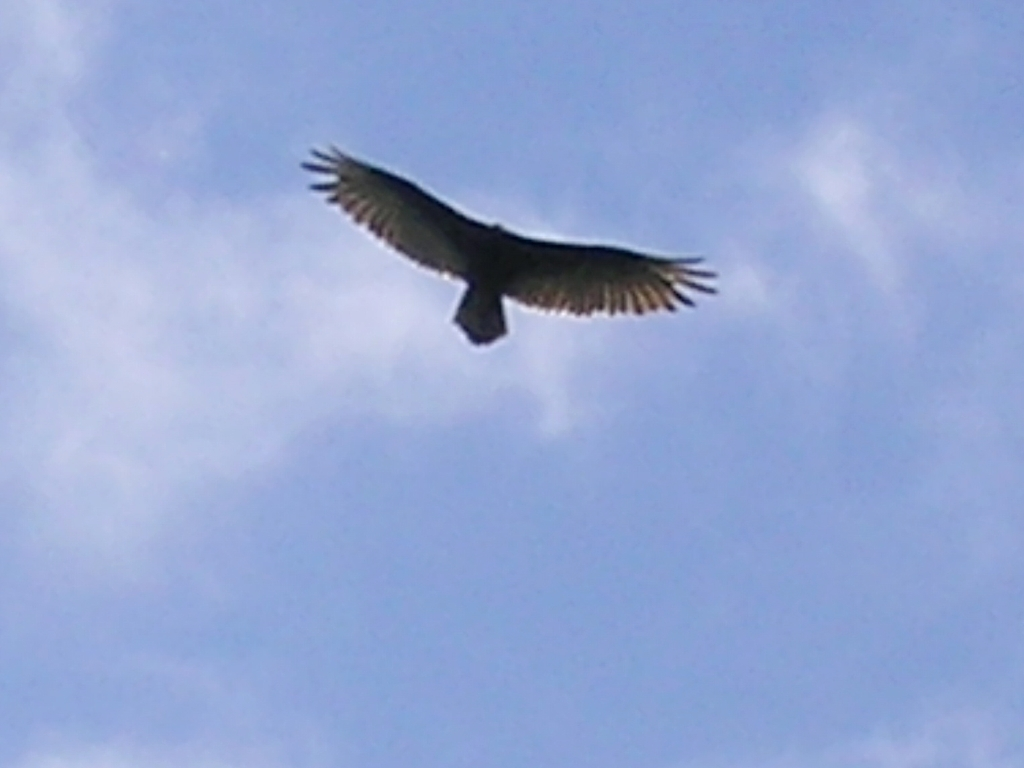What can you infer about the weather conditions in the image? Based on the image, the weather appears to be fairly clear with some scattered clouds. The visibility is good as the sky further away is visible, and there are no signs of precipitation or fog. The open sky and clear conditions seem ideal for birds to soar and glide. 